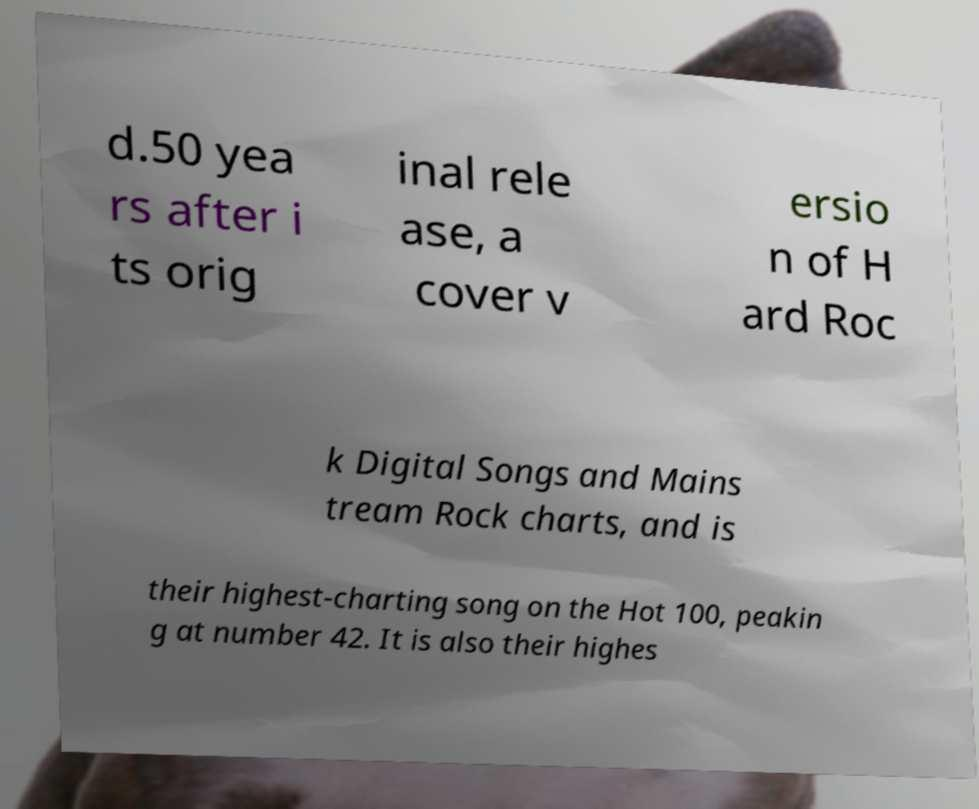Please identify and transcribe the text found in this image. d.50 yea rs after i ts orig inal rele ase, a cover v ersio n of H ard Roc k Digital Songs and Mains tream Rock charts, and is their highest-charting song on the Hot 100, peakin g at number 42. It is also their highes 